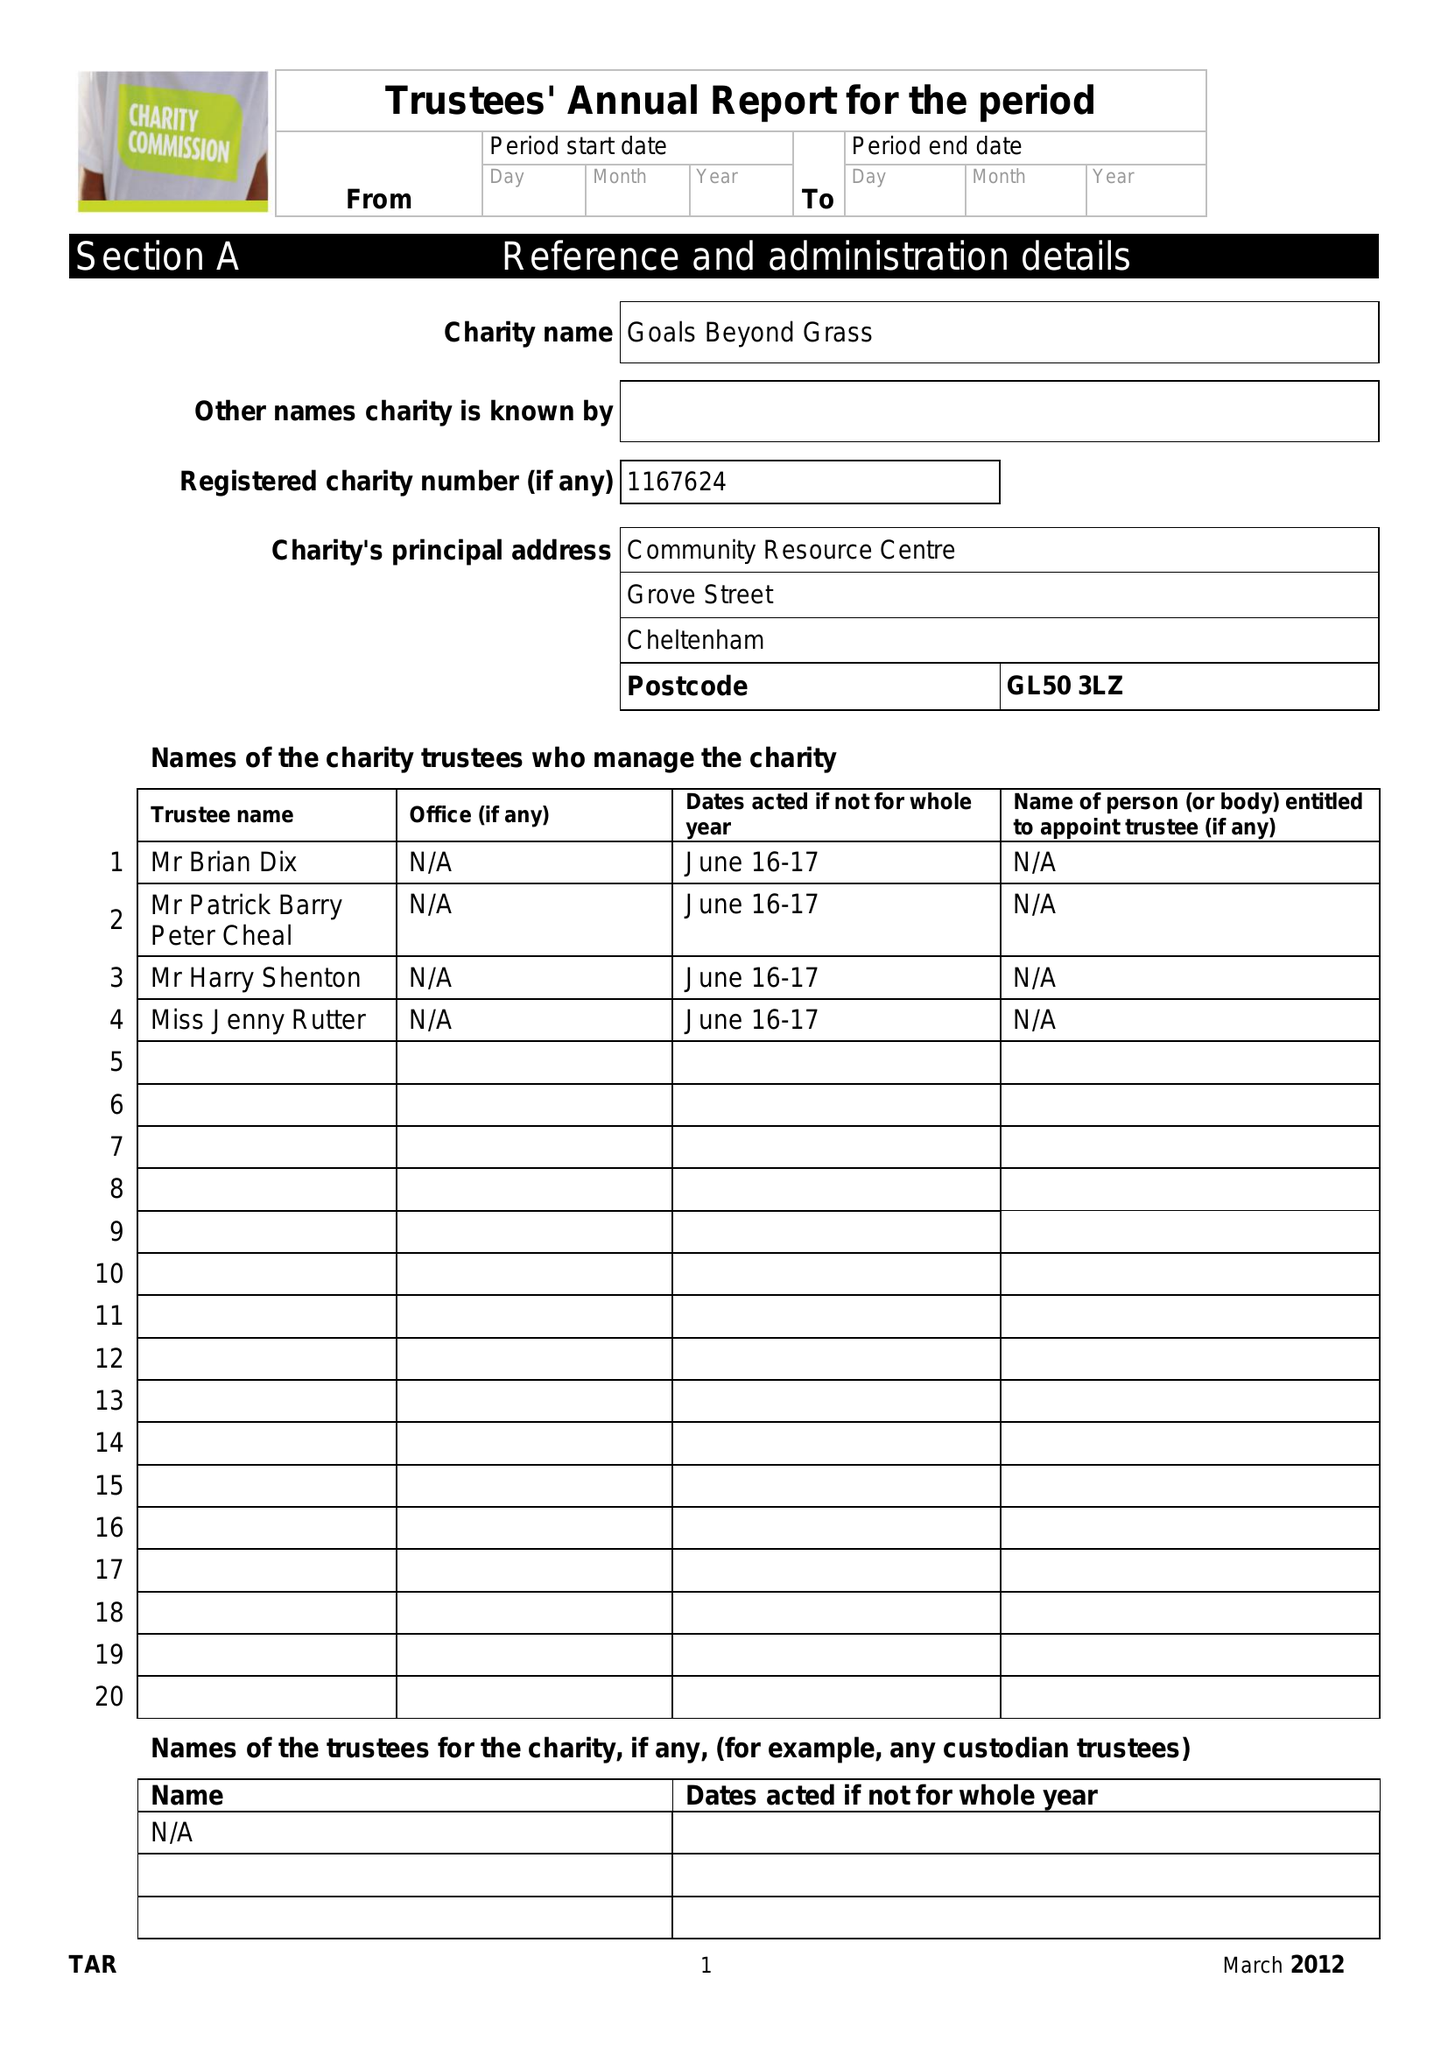What is the value for the report_date?
Answer the question using a single word or phrase. 2017-06-13 